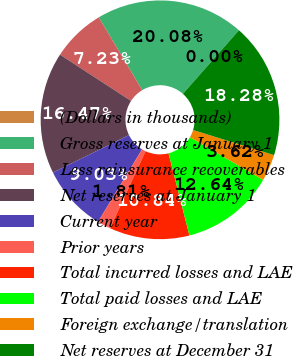<chart> <loc_0><loc_0><loc_500><loc_500><pie_chart><fcel>(Dollars in thousands)<fcel>Gross reserves at January 1<fcel>Less reinsurance recoverables<fcel>Net reserves at January 1<fcel>Current year<fcel>Prior years<fcel>Total incurred losses and LAE<fcel>Total paid losses and LAE<fcel>Foreign exchange/translation<fcel>Net reserves at December 31<nl><fcel>0.0%<fcel>20.08%<fcel>7.23%<fcel>16.47%<fcel>9.03%<fcel>1.81%<fcel>10.84%<fcel>12.64%<fcel>3.62%<fcel>18.28%<nl></chart> 